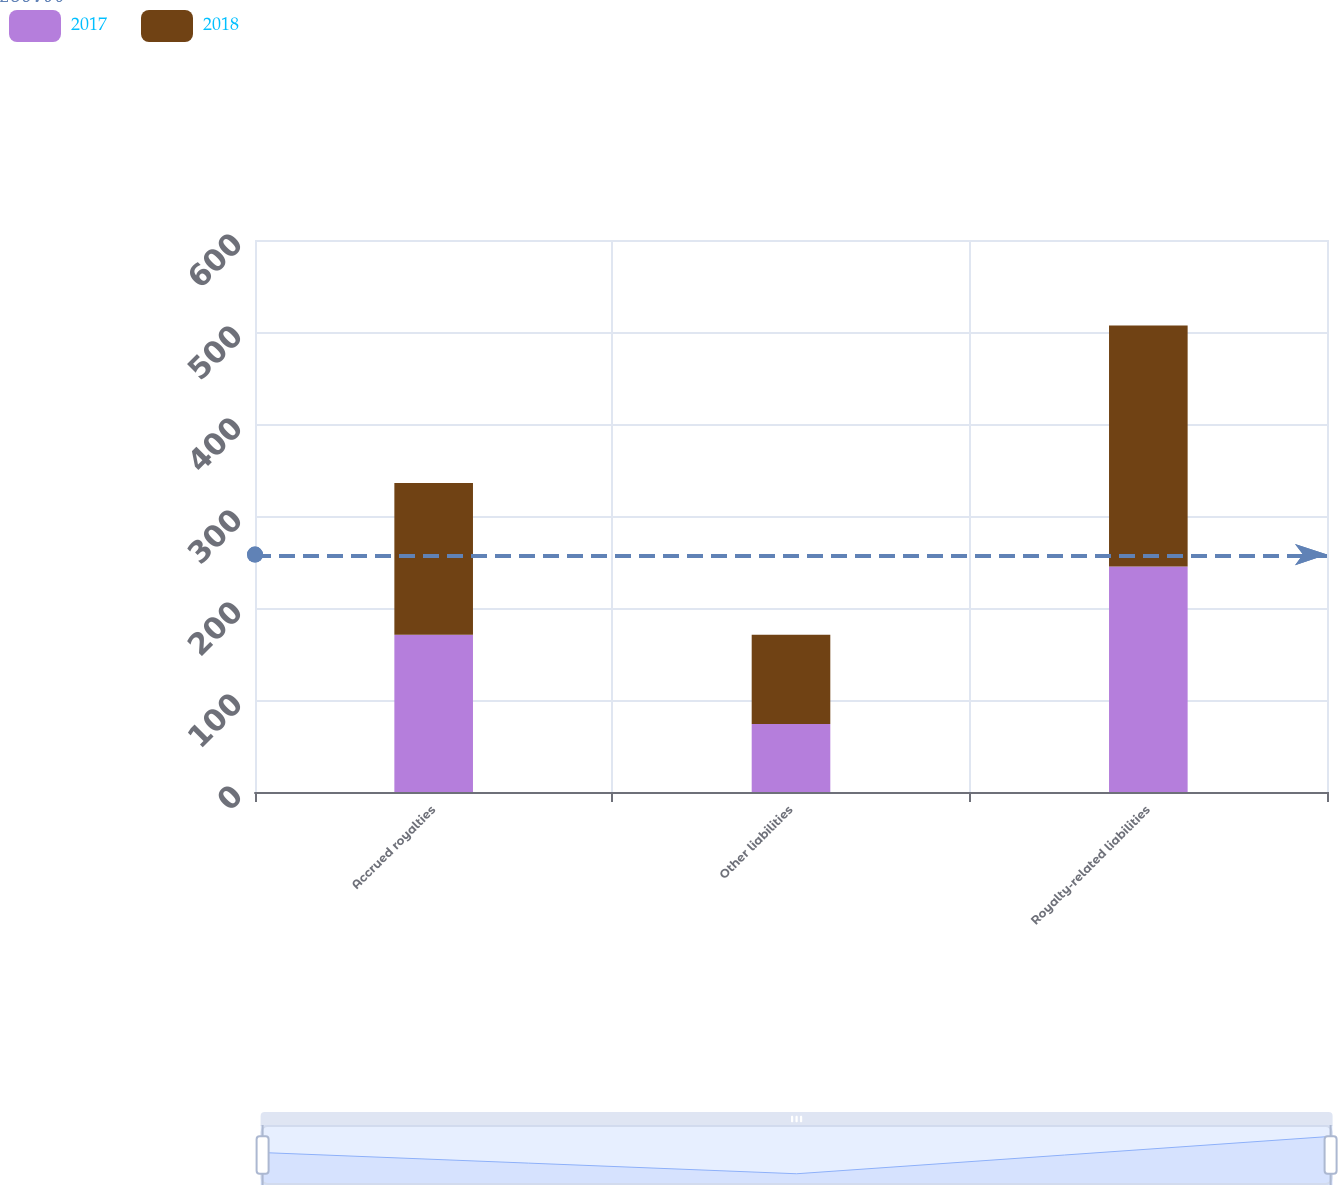Convert chart to OTSL. <chart><loc_0><loc_0><loc_500><loc_500><stacked_bar_chart><ecel><fcel>Accrued royalties<fcel>Other liabilities<fcel>Royalty-related liabilities<nl><fcel>2017<fcel>171<fcel>74<fcel>245<nl><fcel>2018<fcel>165<fcel>97<fcel>262<nl></chart> 